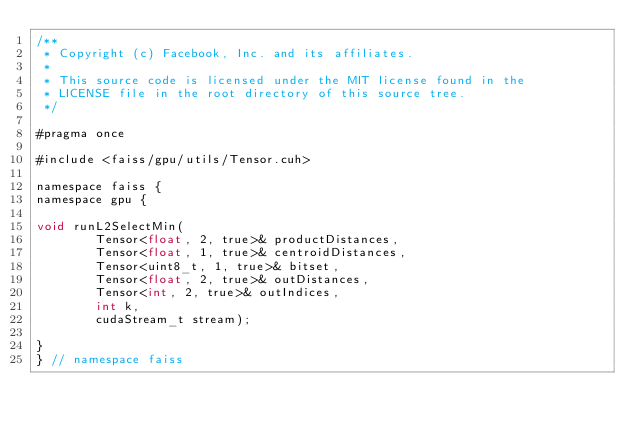<code> <loc_0><loc_0><loc_500><loc_500><_Cuda_>/**
 * Copyright (c) Facebook, Inc. and its affiliates.
 *
 * This source code is licensed under the MIT license found in the
 * LICENSE file in the root directory of this source tree.
 */

#pragma once

#include <faiss/gpu/utils/Tensor.cuh>

namespace faiss {
namespace gpu {

void runL2SelectMin(
        Tensor<float, 2, true>& productDistances,
        Tensor<float, 1, true>& centroidDistances,
        Tensor<uint8_t, 1, true>& bitset,
        Tensor<float, 2, true>& outDistances,
        Tensor<int, 2, true>& outIndices,
        int k,
        cudaStream_t stream);

}
} // namespace faiss
</code> 